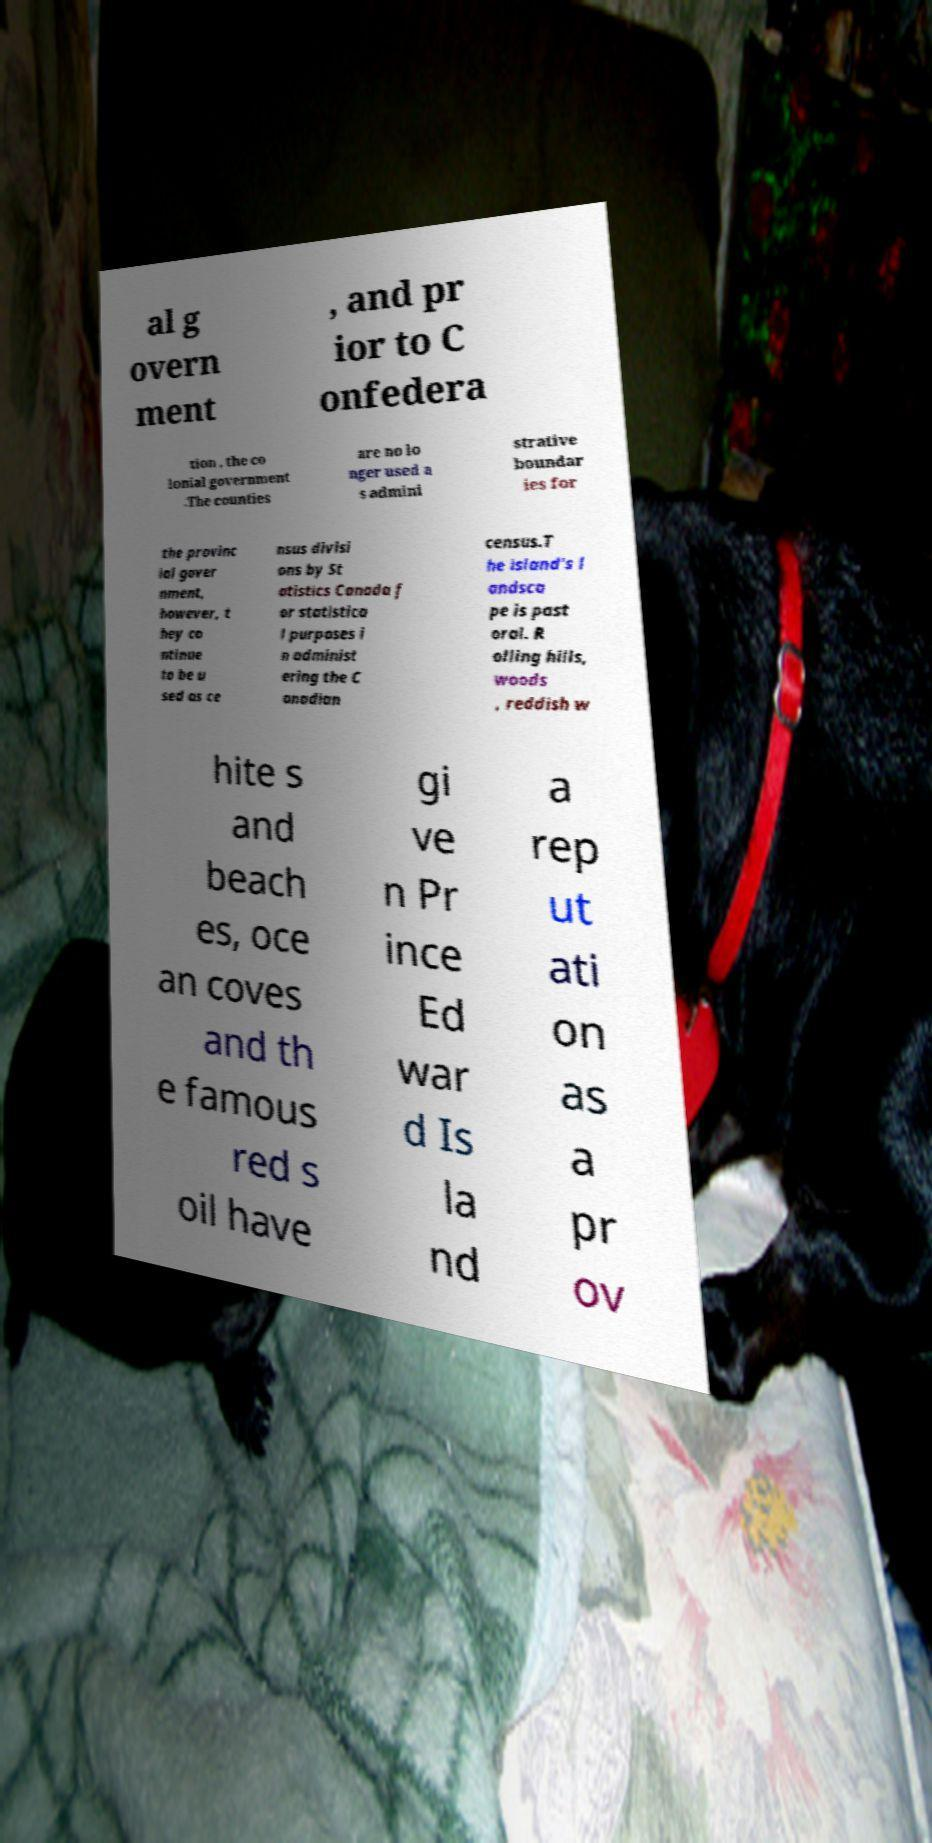Could you extract and type out the text from this image? al g overn ment , and pr ior to C onfedera tion , the co lonial government .The counties are no lo nger used a s admini strative boundar ies for the provinc ial gover nment, however, t hey co ntinue to be u sed as ce nsus divisi ons by St atistics Canada f or statistica l purposes i n administ ering the C anadian census.T he island's l andsca pe is past oral. R olling hills, woods , reddish w hite s and beach es, oce an coves and th e famous red s oil have gi ve n Pr ince Ed war d Is la nd a rep ut ati on as a pr ov 